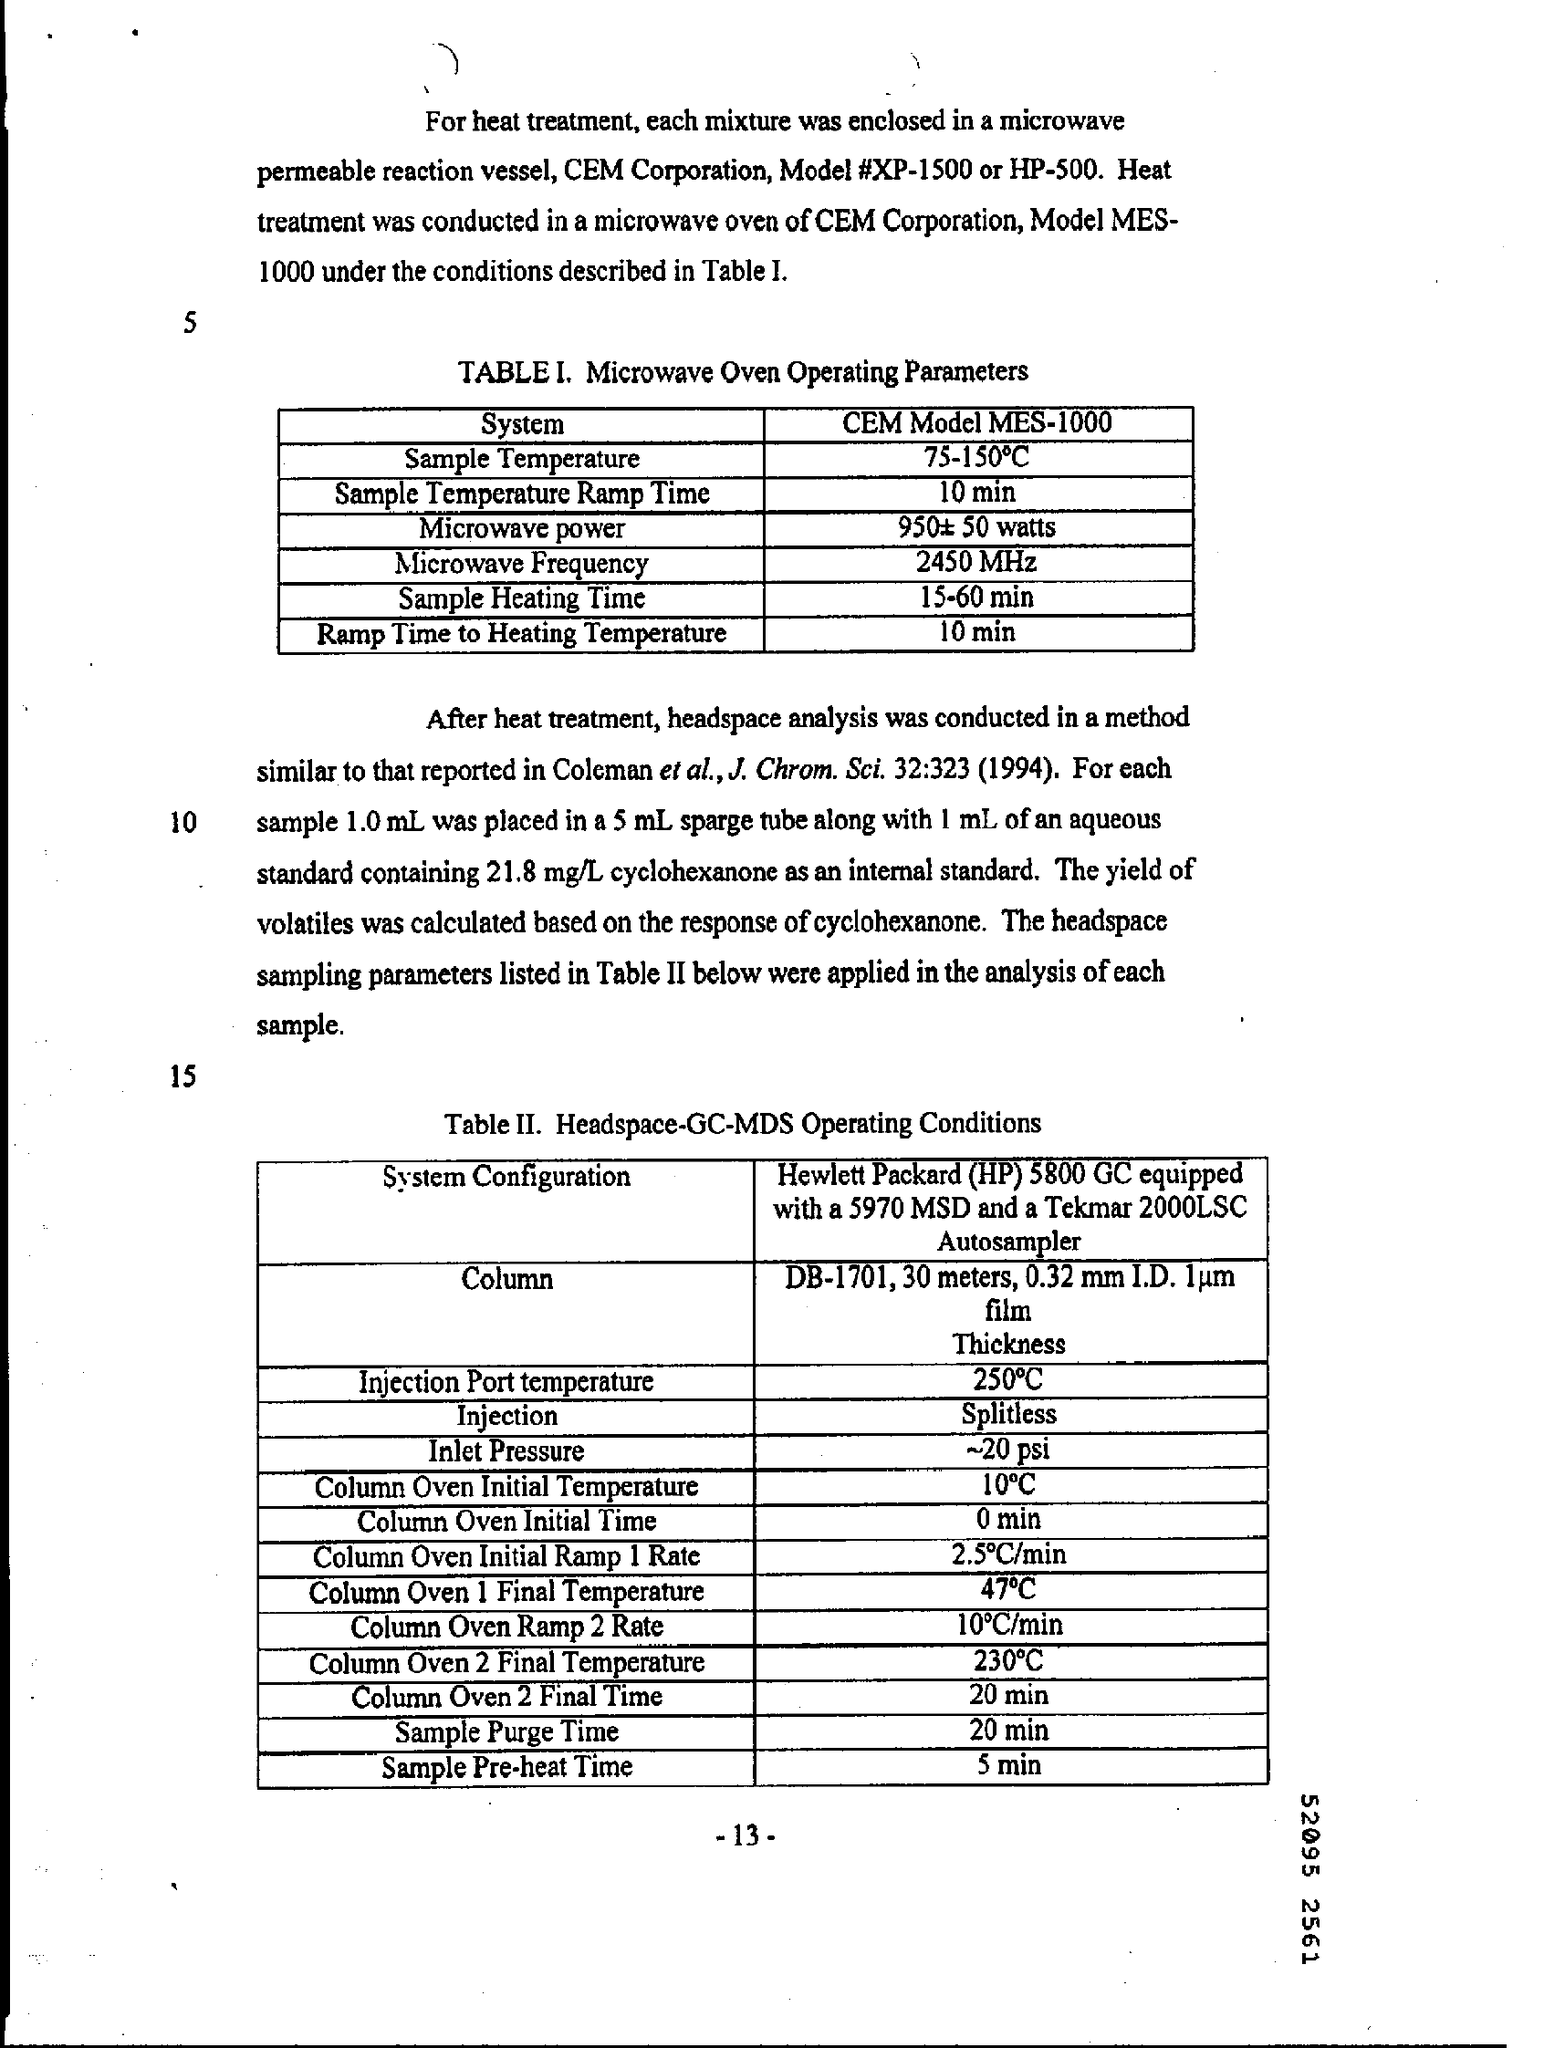Highlight a few significant elements in this photo. Based on "what is the inlet pressure ~20 psi..," I declare that the inlet pressure is approximately 20 pounds per square inch. 